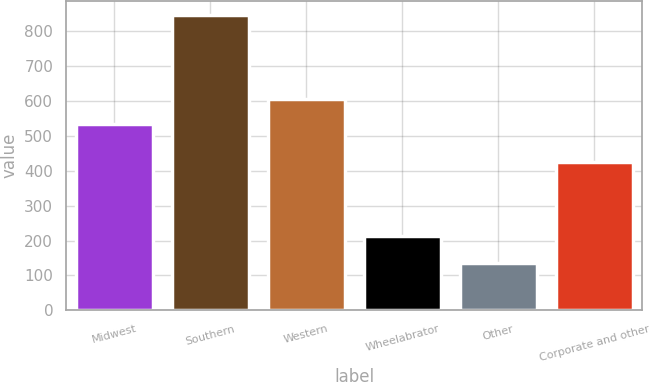<chart> <loc_0><loc_0><loc_500><loc_500><bar_chart><fcel>Midwest<fcel>Southern<fcel>Western<fcel>Wheelabrator<fcel>Other<fcel>Corporate and other<nl><fcel>533<fcel>844<fcel>603.9<fcel>214<fcel>135<fcel>425<nl></chart> 